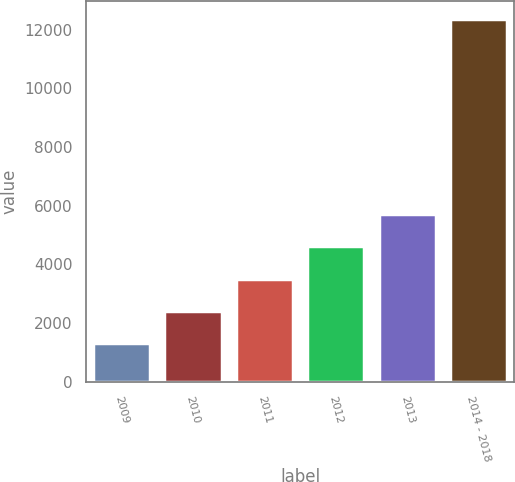Convert chart to OTSL. <chart><loc_0><loc_0><loc_500><loc_500><bar_chart><fcel>2009<fcel>2010<fcel>2011<fcel>2012<fcel>2013<fcel>2014 - 2018<nl><fcel>1308<fcel>2411.8<fcel>3515.6<fcel>4619.4<fcel>5723.2<fcel>12346<nl></chart> 